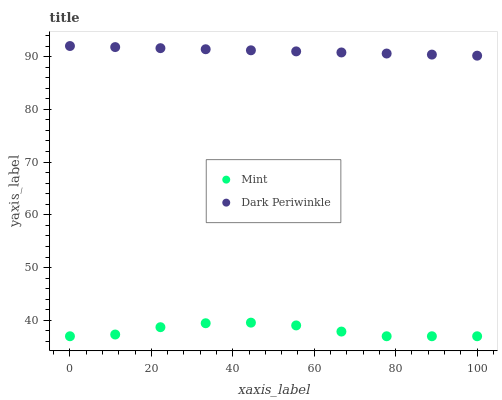Does Mint have the minimum area under the curve?
Answer yes or no. Yes. Does Dark Periwinkle have the maximum area under the curve?
Answer yes or no. Yes. Does Dark Periwinkle have the minimum area under the curve?
Answer yes or no. No. Is Dark Periwinkle the smoothest?
Answer yes or no. Yes. Is Mint the roughest?
Answer yes or no. Yes. Is Dark Periwinkle the roughest?
Answer yes or no. No. Does Mint have the lowest value?
Answer yes or no. Yes. Does Dark Periwinkle have the lowest value?
Answer yes or no. No. Does Dark Periwinkle have the highest value?
Answer yes or no. Yes. Is Mint less than Dark Periwinkle?
Answer yes or no. Yes. Is Dark Periwinkle greater than Mint?
Answer yes or no. Yes. Does Mint intersect Dark Periwinkle?
Answer yes or no. No. 